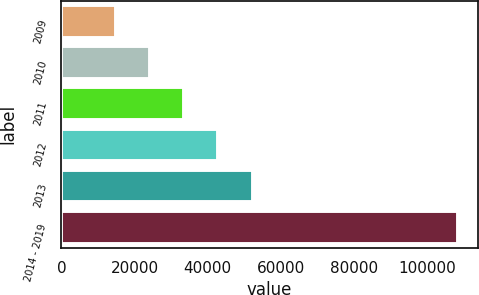Convert chart to OTSL. <chart><loc_0><loc_0><loc_500><loc_500><bar_chart><fcel>2009<fcel>2010<fcel>2011<fcel>2012<fcel>2013<fcel>2014 - 2019<nl><fcel>14792<fcel>24152.1<fcel>33512.2<fcel>42872.3<fcel>52232.4<fcel>108393<nl></chart> 